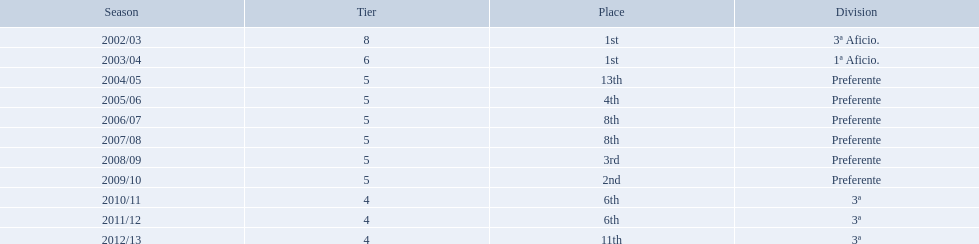Which seasons were played in tier four? 2010/11, 2011/12, 2012/13. Of these seasons, which resulted in 6th place? 2010/11, 2011/12. Which of the remaining happened last? 2011/12. How many times did  internacional de madrid cf come in 6th place? 6th, 6th. What is the first season that the team came in 6th place? 2010/11. Which season after the first did they place in 6th again? 2011/12. 